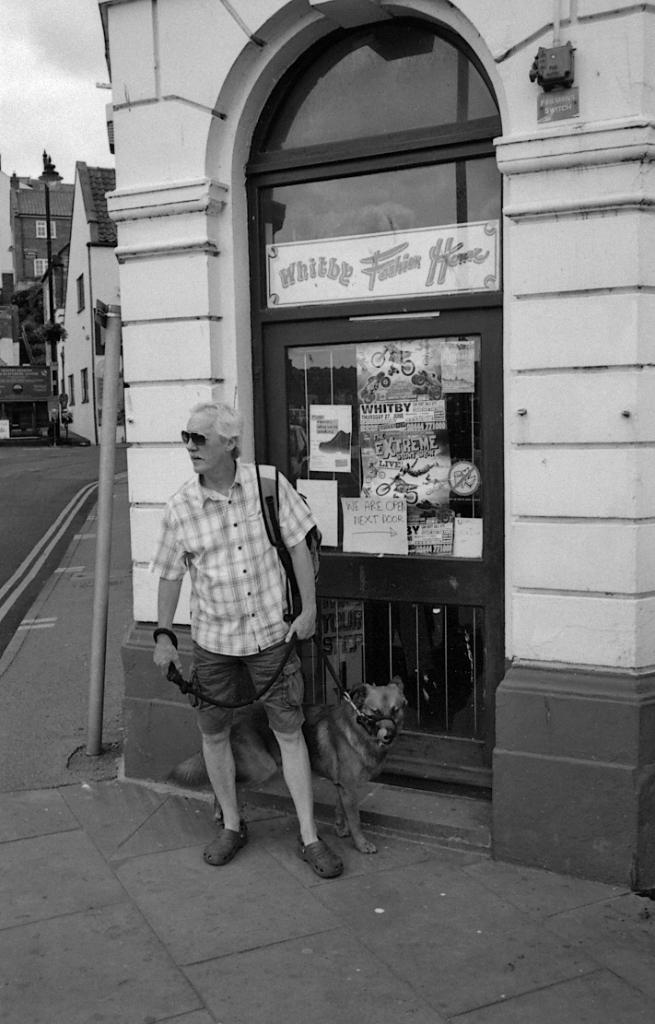What is the person holding in the image? The person is holding a belt tied to a dog. What can be seen behind the person? There is a building behind the person. What is on the door in the image? There are posters on a door. What is present on the left side of the image? There are buildings and trees on the left side of the image. How many birds are flying in a flock in the image? There are no birds or flocks present in the image. 